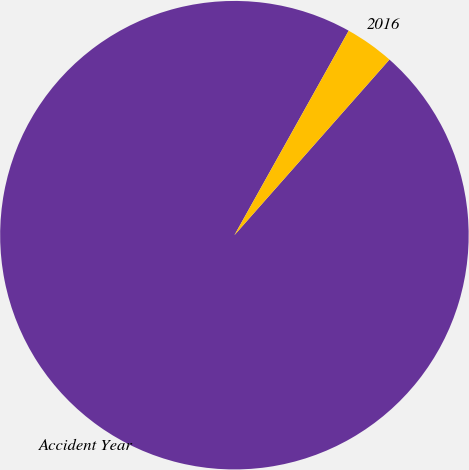Convert chart to OTSL. <chart><loc_0><loc_0><loc_500><loc_500><pie_chart><fcel>Accident Year<fcel>2016<nl><fcel>96.6%<fcel>3.4%<nl></chart> 